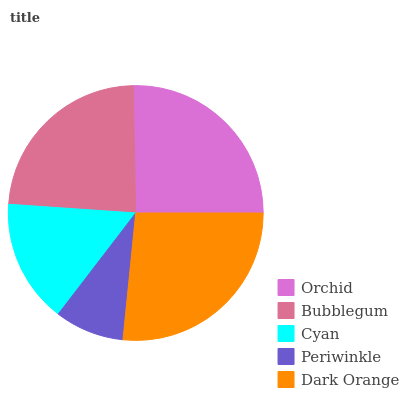Is Periwinkle the minimum?
Answer yes or no. Yes. Is Dark Orange the maximum?
Answer yes or no. Yes. Is Bubblegum the minimum?
Answer yes or no. No. Is Bubblegum the maximum?
Answer yes or no. No. Is Orchid greater than Bubblegum?
Answer yes or no. Yes. Is Bubblegum less than Orchid?
Answer yes or no. Yes. Is Bubblegum greater than Orchid?
Answer yes or no. No. Is Orchid less than Bubblegum?
Answer yes or no. No. Is Bubblegum the high median?
Answer yes or no. Yes. Is Bubblegum the low median?
Answer yes or no. Yes. Is Periwinkle the high median?
Answer yes or no. No. Is Orchid the low median?
Answer yes or no. No. 